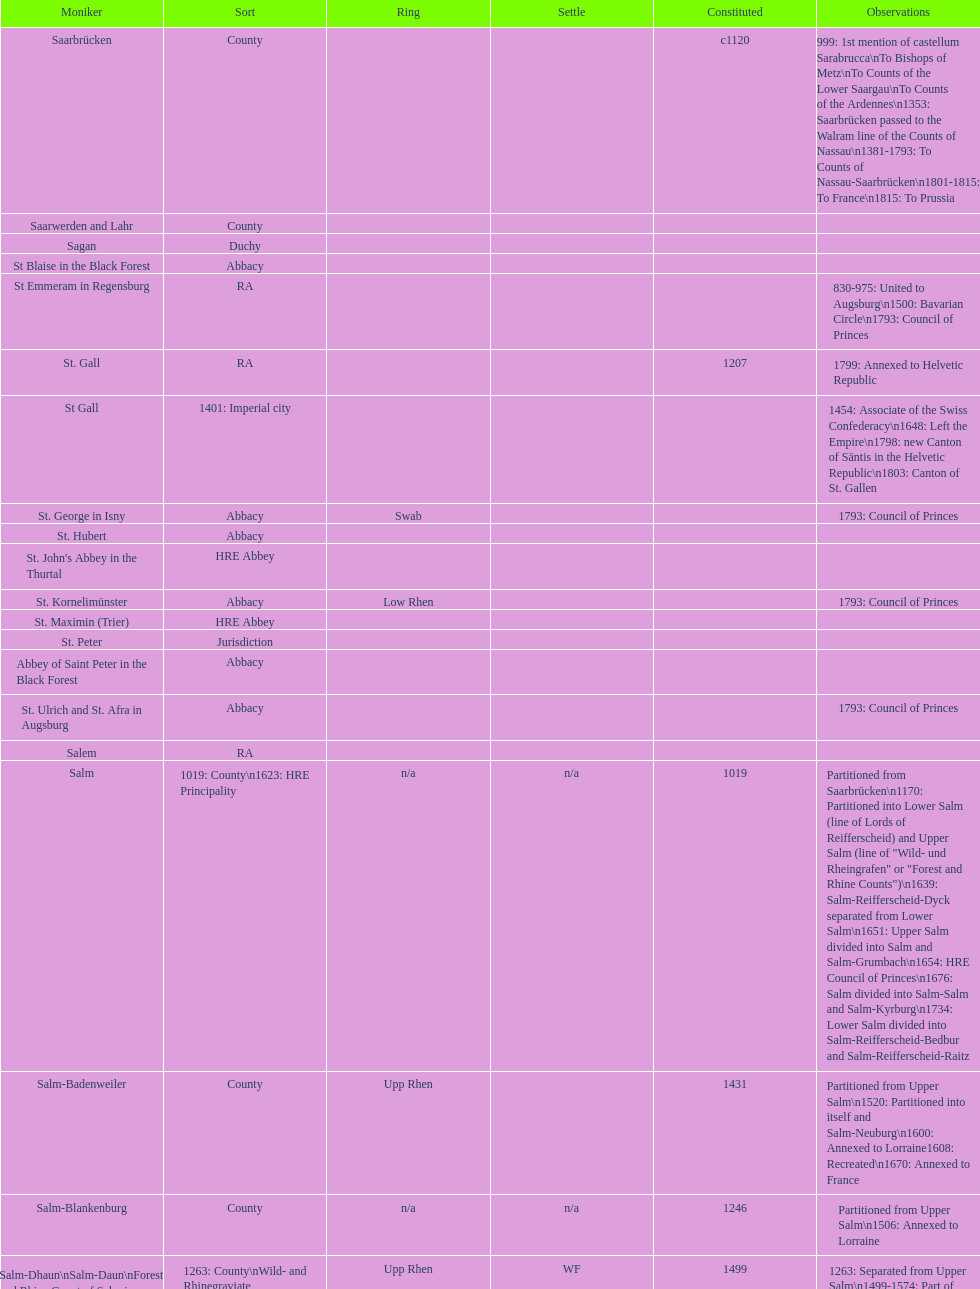Which bench is represented the most? PR. 